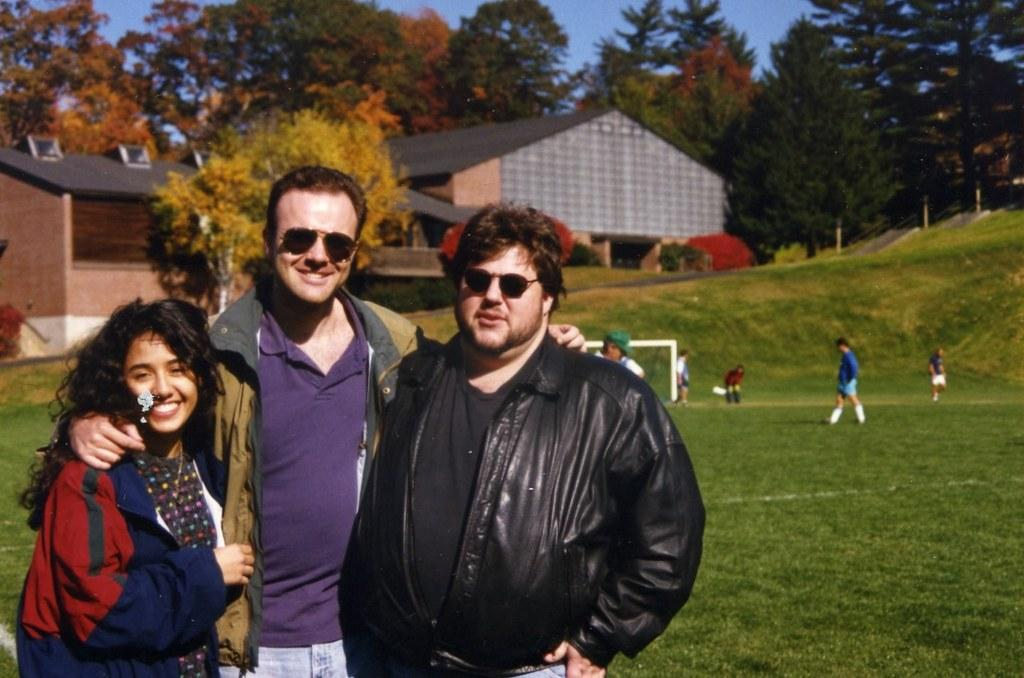Who or what can be seen in the image? There are people in the image. What type of terrain is visible in the image? There is grass in the image. What type of structures are present in the image? There are houses in the image. What else can be seen in the image besides people and houses? There are trees in the image. What is visible at the top of the image? The sky is visible at the top of the image. What type of fruit is being dropped by the actor in the image? There is no actor or fruit present in the image. What role does the actor play in the image? There is no actor present in the image, so it is not possible to determine their role. 